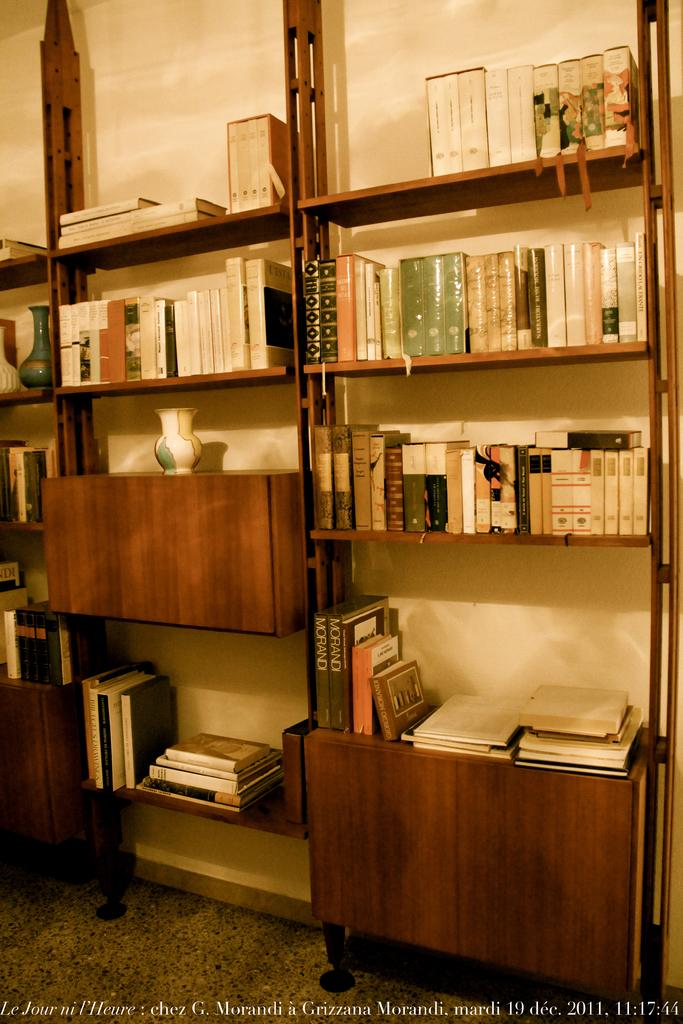What objects can be seen on the shelves in the image? There are books on the shelves in the image. What can be found on the left side of the image? There are vases on the left side of the image. Is there any text or writing visible in the image? Yes, there is writing on the bottom side of the image. Can you see any pipes in the image? There are no pipes visible in the image. What type of observation can be made about the weather in the image? The image does not provide any information about the weather, so no observation can be made. 